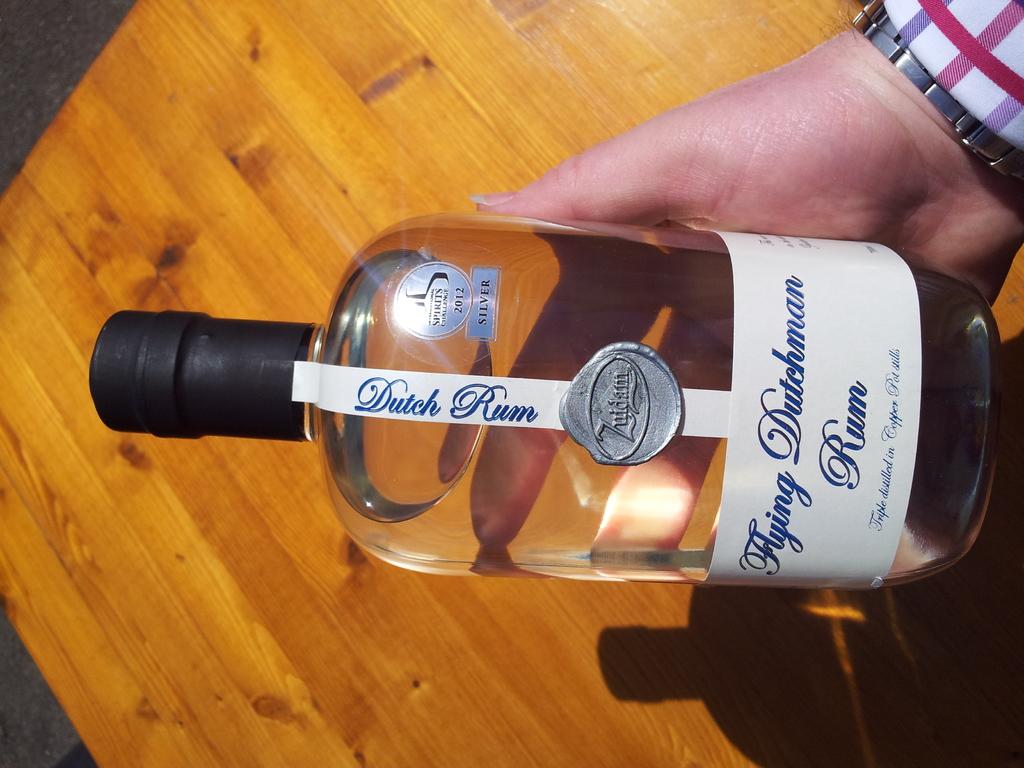What are the first two words printed on this label, on the narrow part, near the neck of the bottle?
Offer a terse response. Dutch rum. 